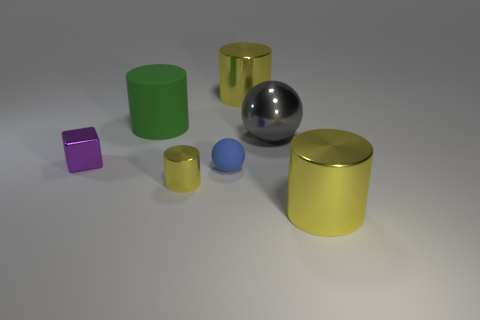Subtract all large green rubber cylinders. How many cylinders are left? 3 Subtract all blue balls. How many balls are left? 1 Subtract all red spheres. How many yellow cylinders are left? 3 Add 1 tiny blue rubber spheres. How many objects exist? 8 Subtract 1 cylinders. How many cylinders are left? 3 Subtract all cubes. How many objects are left? 6 Subtract all blue rubber spheres. Subtract all metal things. How many objects are left? 1 Add 5 small blue matte things. How many small blue matte things are left? 6 Add 1 small blue balls. How many small blue balls exist? 2 Subtract 0 red balls. How many objects are left? 7 